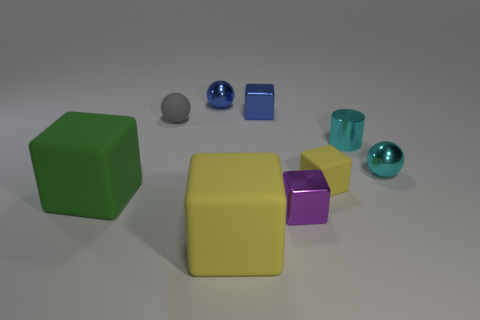How many large yellow rubber blocks are left of the yellow cube that is behind the small block in front of the tiny yellow matte object?
Provide a succinct answer. 1. How many brown things are metallic blocks or small things?
Your answer should be compact. 0. There is a purple metal cube; is it the same size as the rubber cube that is to the left of the rubber sphere?
Your answer should be very brief. No. What material is the big yellow object that is the same shape as the small purple shiny object?
Your answer should be very brief. Rubber. How many other things are the same size as the cyan cylinder?
Ensure brevity in your answer.  6. There is a tiny matte thing that is in front of the tiny cylinder that is behind the tiny metallic sphere in front of the gray matte object; what is its shape?
Ensure brevity in your answer.  Cube. The thing that is both to the right of the small purple block and behind the tiny cyan ball has what shape?
Give a very brief answer. Cylinder. What number of things are green cylinders or yellow rubber cubes that are in front of the green cube?
Keep it short and to the point. 1. Do the purple object and the small blue cube have the same material?
Ensure brevity in your answer.  Yes. How many other objects are there of the same shape as the small gray matte object?
Make the answer very short. 2. 